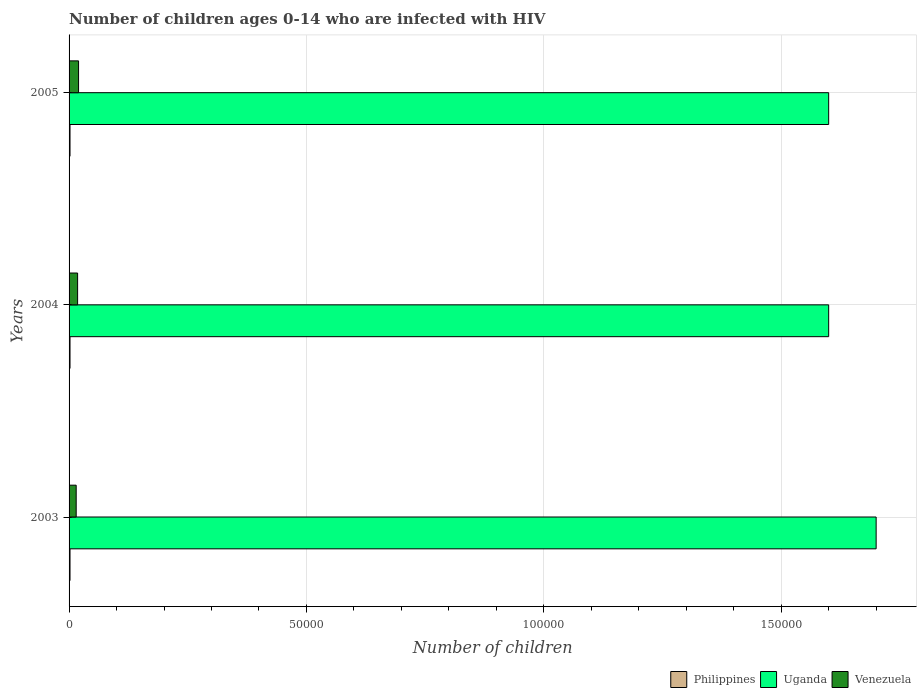Are the number of bars per tick equal to the number of legend labels?
Keep it short and to the point. Yes. Are the number of bars on each tick of the Y-axis equal?
Your response must be concise. Yes. How many bars are there on the 1st tick from the top?
Provide a succinct answer. 3. How many bars are there on the 2nd tick from the bottom?
Ensure brevity in your answer.  3. In how many cases, is the number of bars for a given year not equal to the number of legend labels?
Your answer should be very brief. 0. What is the number of HIV infected children in Philippines in 2003?
Provide a succinct answer. 200. Across all years, what is the maximum number of HIV infected children in Philippines?
Offer a very short reply. 200. Across all years, what is the minimum number of HIV infected children in Philippines?
Give a very brief answer. 200. In which year was the number of HIV infected children in Uganda maximum?
Ensure brevity in your answer.  2003. In which year was the number of HIV infected children in Uganda minimum?
Offer a terse response. 2004. What is the total number of HIV infected children in Venezuela in the graph?
Your response must be concise. 5300. What is the difference between the number of HIV infected children in Venezuela in 2003 and that in 2004?
Provide a succinct answer. -300. What is the difference between the number of HIV infected children in Philippines in 2005 and the number of HIV infected children in Venezuela in 2003?
Ensure brevity in your answer.  -1300. What is the average number of HIV infected children in Venezuela per year?
Your response must be concise. 1766.67. In the year 2005, what is the difference between the number of HIV infected children in Philippines and number of HIV infected children in Venezuela?
Give a very brief answer. -1800. Is the number of HIV infected children in Uganda in 2004 less than that in 2005?
Your answer should be very brief. No. What is the difference between the highest and the second highest number of HIV infected children in Philippines?
Ensure brevity in your answer.  0. What is the difference between the highest and the lowest number of HIV infected children in Uganda?
Make the answer very short. 10000. In how many years, is the number of HIV infected children in Philippines greater than the average number of HIV infected children in Philippines taken over all years?
Your answer should be very brief. 0. What does the 2nd bar from the top in 2004 represents?
Keep it short and to the point. Uganda. What does the 3rd bar from the bottom in 2005 represents?
Your answer should be compact. Venezuela. Is it the case that in every year, the sum of the number of HIV infected children in Philippines and number of HIV infected children in Venezuela is greater than the number of HIV infected children in Uganda?
Offer a very short reply. No. How many years are there in the graph?
Your answer should be compact. 3. What is the difference between two consecutive major ticks on the X-axis?
Your answer should be compact. 5.00e+04. Does the graph contain grids?
Provide a succinct answer. Yes. How many legend labels are there?
Keep it short and to the point. 3. How are the legend labels stacked?
Make the answer very short. Horizontal. What is the title of the graph?
Give a very brief answer. Number of children ages 0-14 who are infected with HIV. Does "Vanuatu" appear as one of the legend labels in the graph?
Make the answer very short. No. What is the label or title of the X-axis?
Give a very brief answer. Number of children. What is the Number of children in Venezuela in 2003?
Make the answer very short. 1500. What is the Number of children in Venezuela in 2004?
Your response must be concise. 1800. What is the Number of children in Philippines in 2005?
Keep it short and to the point. 200. Across all years, what is the maximum Number of children of Uganda?
Offer a very short reply. 1.70e+05. Across all years, what is the minimum Number of children in Philippines?
Your answer should be compact. 200. Across all years, what is the minimum Number of children in Uganda?
Offer a very short reply. 1.60e+05. Across all years, what is the minimum Number of children in Venezuela?
Your answer should be compact. 1500. What is the total Number of children in Philippines in the graph?
Your response must be concise. 600. What is the total Number of children of Venezuela in the graph?
Offer a terse response. 5300. What is the difference between the Number of children in Philippines in 2003 and that in 2004?
Your answer should be compact. 0. What is the difference between the Number of children of Venezuela in 2003 and that in 2004?
Make the answer very short. -300. What is the difference between the Number of children of Uganda in 2003 and that in 2005?
Your response must be concise. 10000. What is the difference between the Number of children of Venezuela in 2003 and that in 2005?
Offer a very short reply. -500. What is the difference between the Number of children in Philippines in 2004 and that in 2005?
Provide a short and direct response. 0. What is the difference between the Number of children of Venezuela in 2004 and that in 2005?
Offer a terse response. -200. What is the difference between the Number of children of Philippines in 2003 and the Number of children of Uganda in 2004?
Your answer should be compact. -1.60e+05. What is the difference between the Number of children in Philippines in 2003 and the Number of children in Venezuela in 2004?
Offer a very short reply. -1600. What is the difference between the Number of children of Uganda in 2003 and the Number of children of Venezuela in 2004?
Provide a short and direct response. 1.68e+05. What is the difference between the Number of children in Philippines in 2003 and the Number of children in Uganda in 2005?
Provide a succinct answer. -1.60e+05. What is the difference between the Number of children of Philippines in 2003 and the Number of children of Venezuela in 2005?
Provide a succinct answer. -1800. What is the difference between the Number of children of Uganda in 2003 and the Number of children of Venezuela in 2005?
Ensure brevity in your answer.  1.68e+05. What is the difference between the Number of children in Philippines in 2004 and the Number of children in Uganda in 2005?
Give a very brief answer. -1.60e+05. What is the difference between the Number of children in Philippines in 2004 and the Number of children in Venezuela in 2005?
Keep it short and to the point. -1800. What is the difference between the Number of children of Uganda in 2004 and the Number of children of Venezuela in 2005?
Ensure brevity in your answer.  1.58e+05. What is the average Number of children in Uganda per year?
Your answer should be very brief. 1.63e+05. What is the average Number of children in Venezuela per year?
Offer a very short reply. 1766.67. In the year 2003, what is the difference between the Number of children in Philippines and Number of children in Uganda?
Make the answer very short. -1.70e+05. In the year 2003, what is the difference between the Number of children in Philippines and Number of children in Venezuela?
Your response must be concise. -1300. In the year 2003, what is the difference between the Number of children of Uganda and Number of children of Venezuela?
Your answer should be very brief. 1.68e+05. In the year 2004, what is the difference between the Number of children in Philippines and Number of children in Uganda?
Give a very brief answer. -1.60e+05. In the year 2004, what is the difference between the Number of children in Philippines and Number of children in Venezuela?
Make the answer very short. -1600. In the year 2004, what is the difference between the Number of children of Uganda and Number of children of Venezuela?
Your response must be concise. 1.58e+05. In the year 2005, what is the difference between the Number of children of Philippines and Number of children of Uganda?
Make the answer very short. -1.60e+05. In the year 2005, what is the difference between the Number of children of Philippines and Number of children of Venezuela?
Your answer should be compact. -1800. In the year 2005, what is the difference between the Number of children of Uganda and Number of children of Venezuela?
Make the answer very short. 1.58e+05. What is the ratio of the Number of children of Venezuela in 2003 to that in 2004?
Make the answer very short. 0.83. What is the ratio of the Number of children in Philippines in 2003 to that in 2005?
Your answer should be very brief. 1. What is the ratio of the Number of children of Uganda in 2003 to that in 2005?
Offer a terse response. 1.06. What is the ratio of the Number of children of Venezuela in 2003 to that in 2005?
Provide a short and direct response. 0.75. What is the ratio of the Number of children in Uganda in 2004 to that in 2005?
Keep it short and to the point. 1. What is the ratio of the Number of children of Venezuela in 2004 to that in 2005?
Make the answer very short. 0.9. What is the difference between the highest and the second highest Number of children of Philippines?
Your response must be concise. 0. What is the difference between the highest and the lowest Number of children of Uganda?
Offer a very short reply. 10000. 